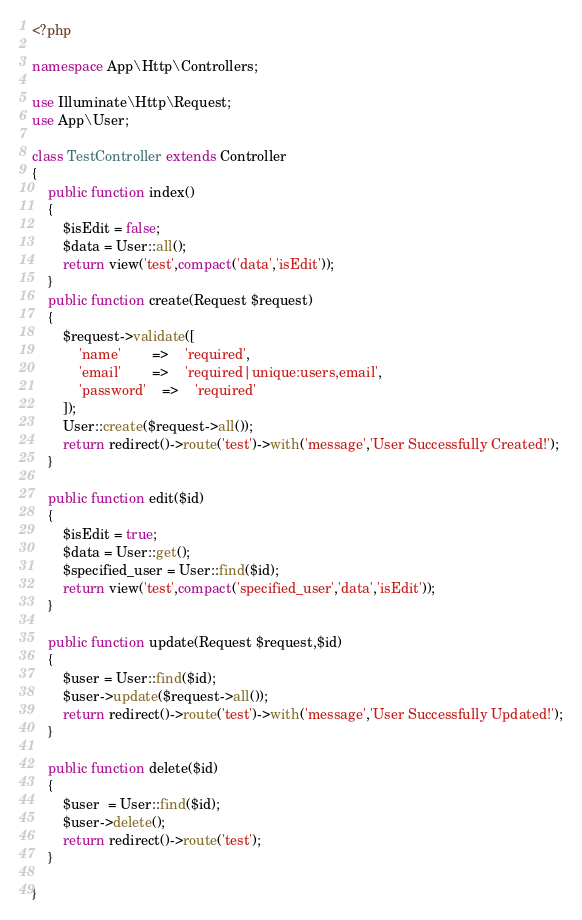<code> <loc_0><loc_0><loc_500><loc_500><_PHP_><?php

namespace App\Http\Controllers;

use Illuminate\Http\Request;
use App\User;

class TestController extends Controller
{
    public function index()
    {
    	$isEdit = false;
    	$data = User::all();
        return view('test',compact('data','isEdit'));
    }
    public function create(Request $request)
    {
    	$request->validate([
    		'name' 		=> 	'required',
    		'email'		=>	'required|unique:users,email',
    		'password'	=>	'required'
    	]);
       	User::create($request->all());
        return redirect()->route('test')->with('message','User Successfully Created!');
    }

    public function edit($id)
    {
    	$isEdit = true;
    	$data = User::get();
    	$specified_user = User::find($id);
    	return view('test',compact('specified_user','data','isEdit'));
    }

    public function update(Request $request,$id)
    {
        $user = User::find($id);
        $user->update($request->all());
        return redirect()->route('test')->with('message','User Successfully Updated!');
    }

    public function delete($id)
    {
    	$user  = User::find($id);
    	$user->delete();
    	return redirect()->route('test'); 
    }

}

</code> 